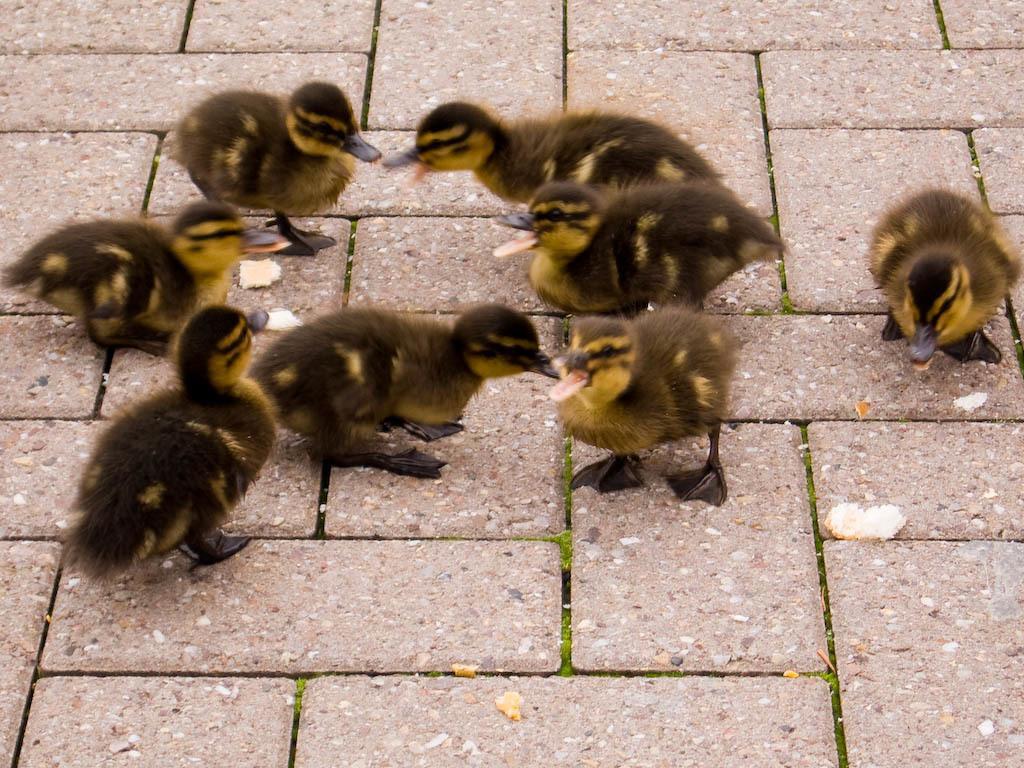Describe this image in one or two sentences. In this image we can see the ducks on the surface. We can also see the pieces of food. 